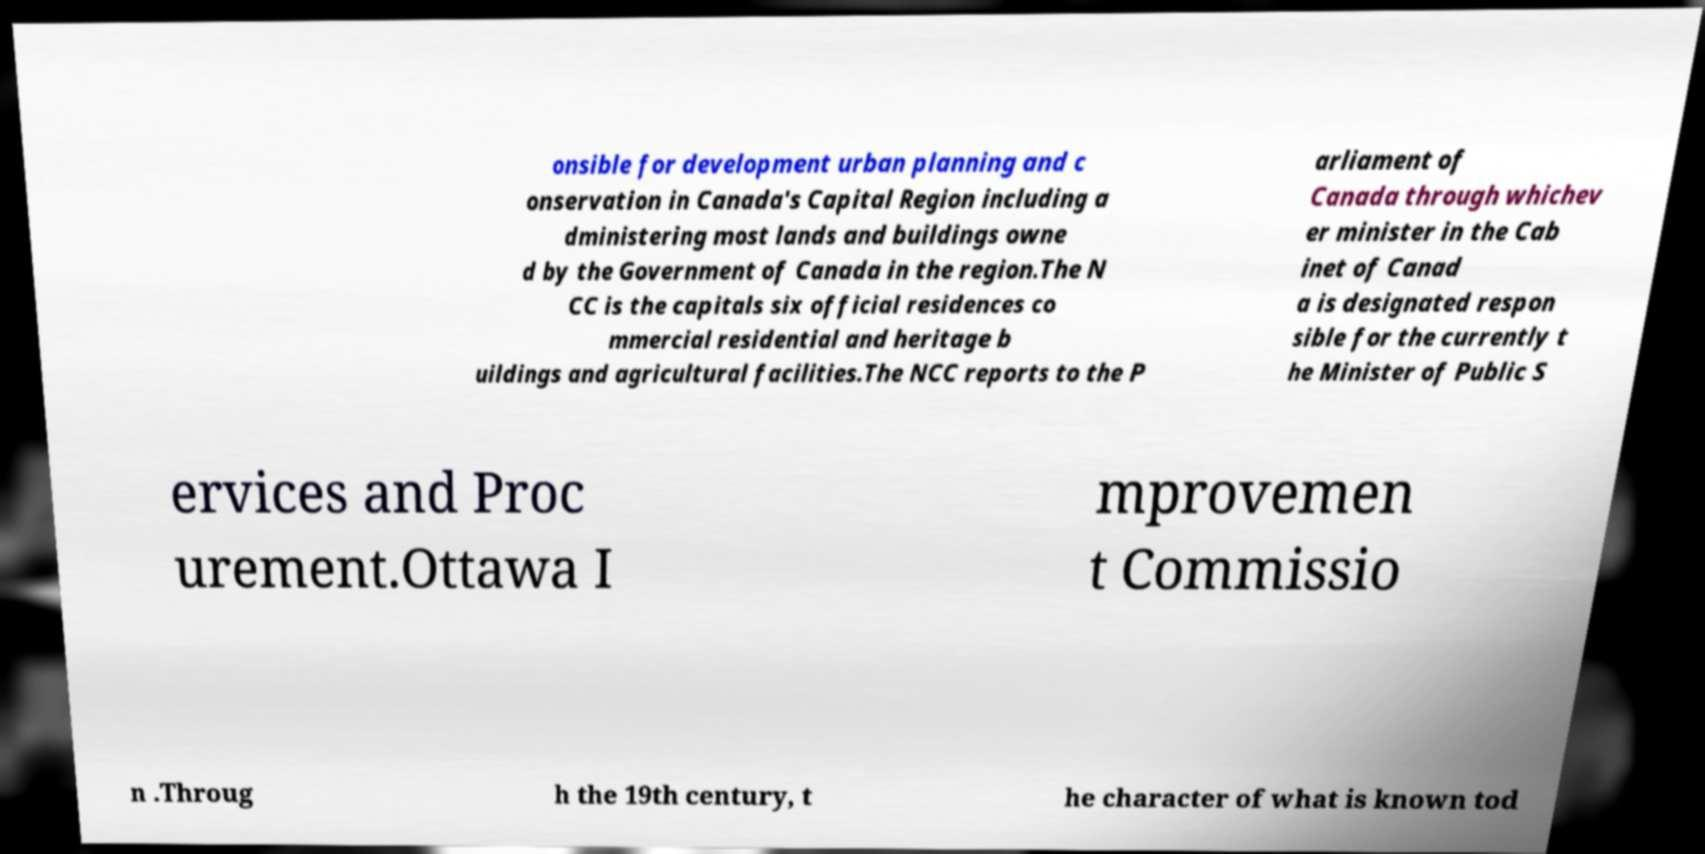For documentation purposes, I need the text within this image transcribed. Could you provide that? onsible for development urban planning and c onservation in Canada's Capital Region including a dministering most lands and buildings owne d by the Government of Canada in the region.The N CC is the capitals six official residences co mmercial residential and heritage b uildings and agricultural facilities.The NCC reports to the P arliament of Canada through whichev er minister in the Cab inet of Canad a is designated respon sible for the currently t he Minister of Public S ervices and Proc urement.Ottawa I mprovemen t Commissio n .Throug h the 19th century, t he character of what is known tod 